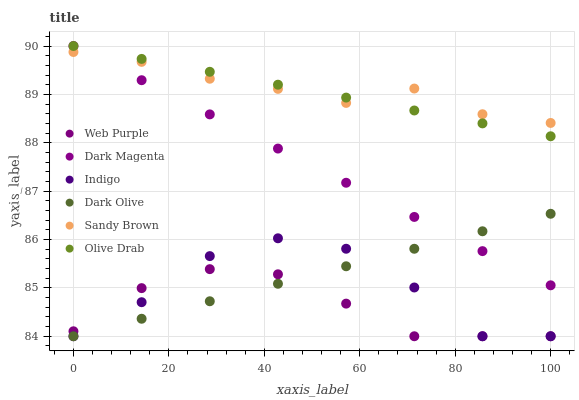Does Web Purple have the minimum area under the curve?
Answer yes or no. Yes. Does Sandy Brown have the maximum area under the curve?
Answer yes or no. Yes. Does Dark Magenta have the minimum area under the curve?
Answer yes or no. No. Does Dark Magenta have the maximum area under the curve?
Answer yes or no. No. Is Dark Magenta the smoothest?
Answer yes or no. Yes. Is Indigo the roughest?
Answer yes or no. Yes. Is Dark Olive the smoothest?
Answer yes or no. No. Is Dark Olive the roughest?
Answer yes or no. No. Does Indigo have the lowest value?
Answer yes or no. Yes. Does Dark Magenta have the lowest value?
Answer yes or no. No. Does Olive Drab have the highest value?
Answer yes or no. Yes. Does Dark Olive have the highest value?
Answer yes or no. No. Is Web Purple less than Olive Drab?
Answer yes or no. Yes. Is Olive Drab greater than Indigo?
Answer yes or no. Yes. Does Dark Olive intersect Dark Magenta?
Answer yes or no. Yes. Is Dark Olive less than Dark Magenta?
Answer yes or no. No. Is Dark Olive greater than Dark Magenta?
Answer yes or no. No. Does Web Purple intersect Olive Drab?
Answer yes or no. No. 